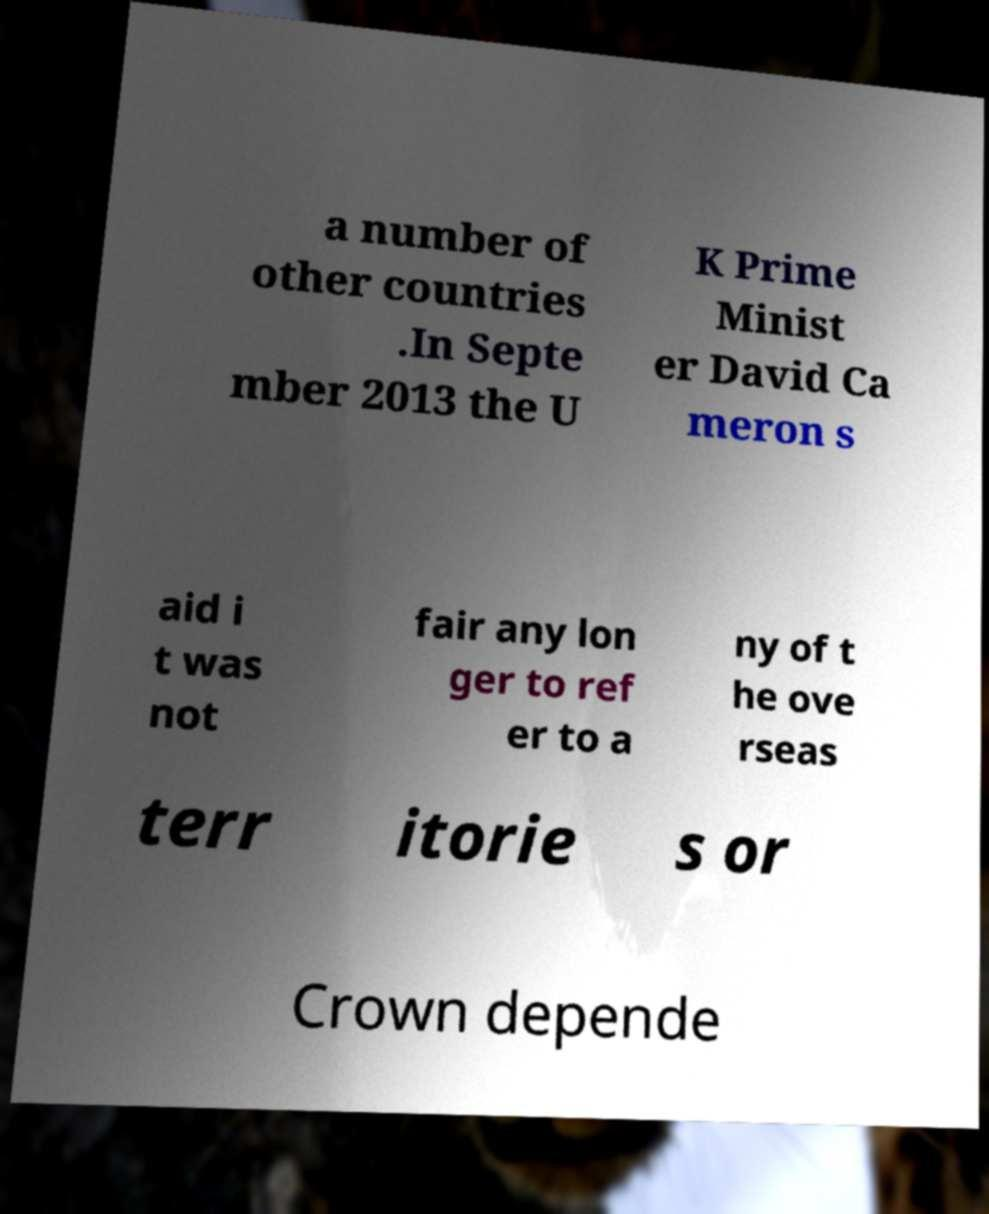I need the written content from this picture converted into text. Can you do that? a number of other countries .In Septe mber 2013 the U K Prime Minist er David Ca meron s aid i t was not fair any lon ger to ref er to a ny of t he ove rseas terr itorie s or Crown depende 